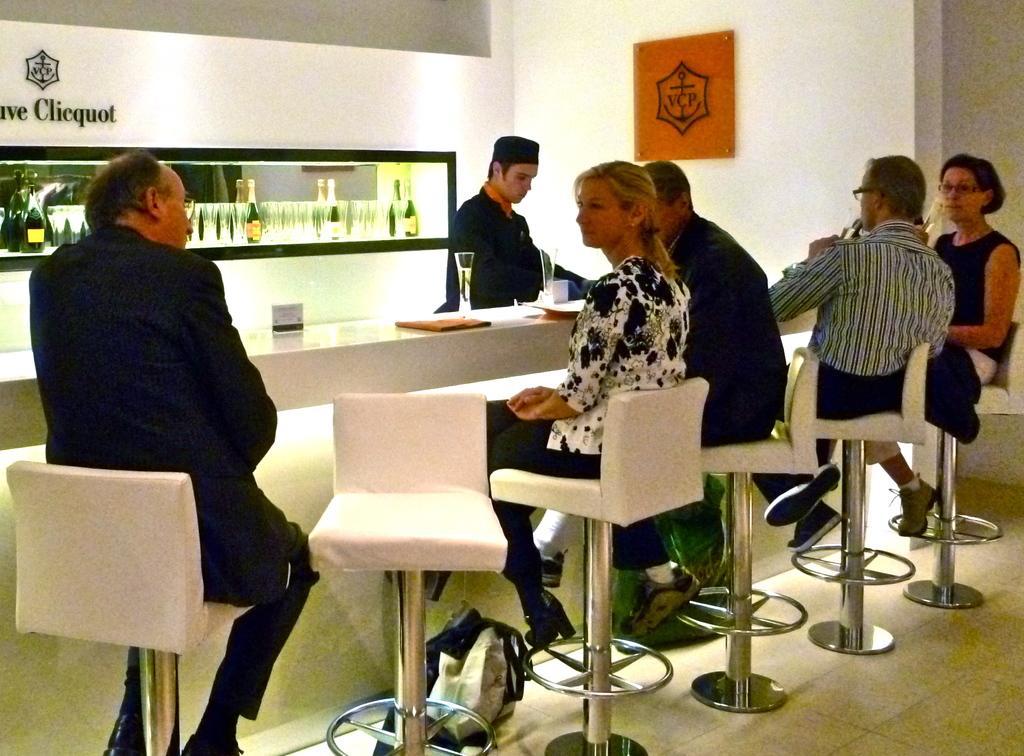How would you summarize this image in a sentence or two? In this image I see 3 men and 2 women who are sitting on chairs and there is a table in front of them on which there are two glasses and I can also see a man over here. In the background I see number of glasses and bottles and on the wall I see few words written. 